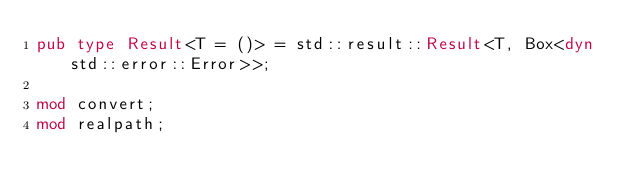<code> <loc_0><loc_0><loc_500><loc_500><_Rust_>pub type Result<T = ()> = std::result::Result<T, Box<dyn std::error::Error>>;

mod convert;
mod realpath;
</code> 